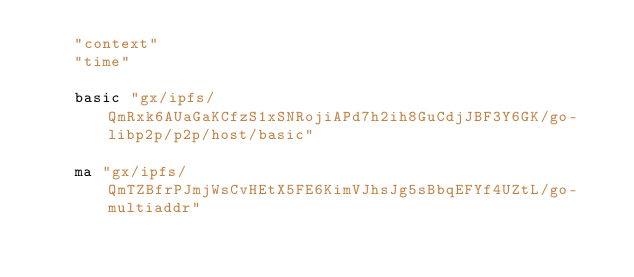<code> <loc_0><loc_0><loc_500><loc_500><_Go_>	"context"
	"time"

	basic "gx/ipfs/QmRxk6AUaGaKCfzS1xSNRojiAPd7h2ih8GuCdjJBF3Y6GK/go-libp2p/p2p/host/basic"

	ma "gx/ipfs/QmTZBfrPJmjWsCvHEtX5FE6KimVJhsJg5sBbqEFYf4UZtL/go-multiaddr"</code> 